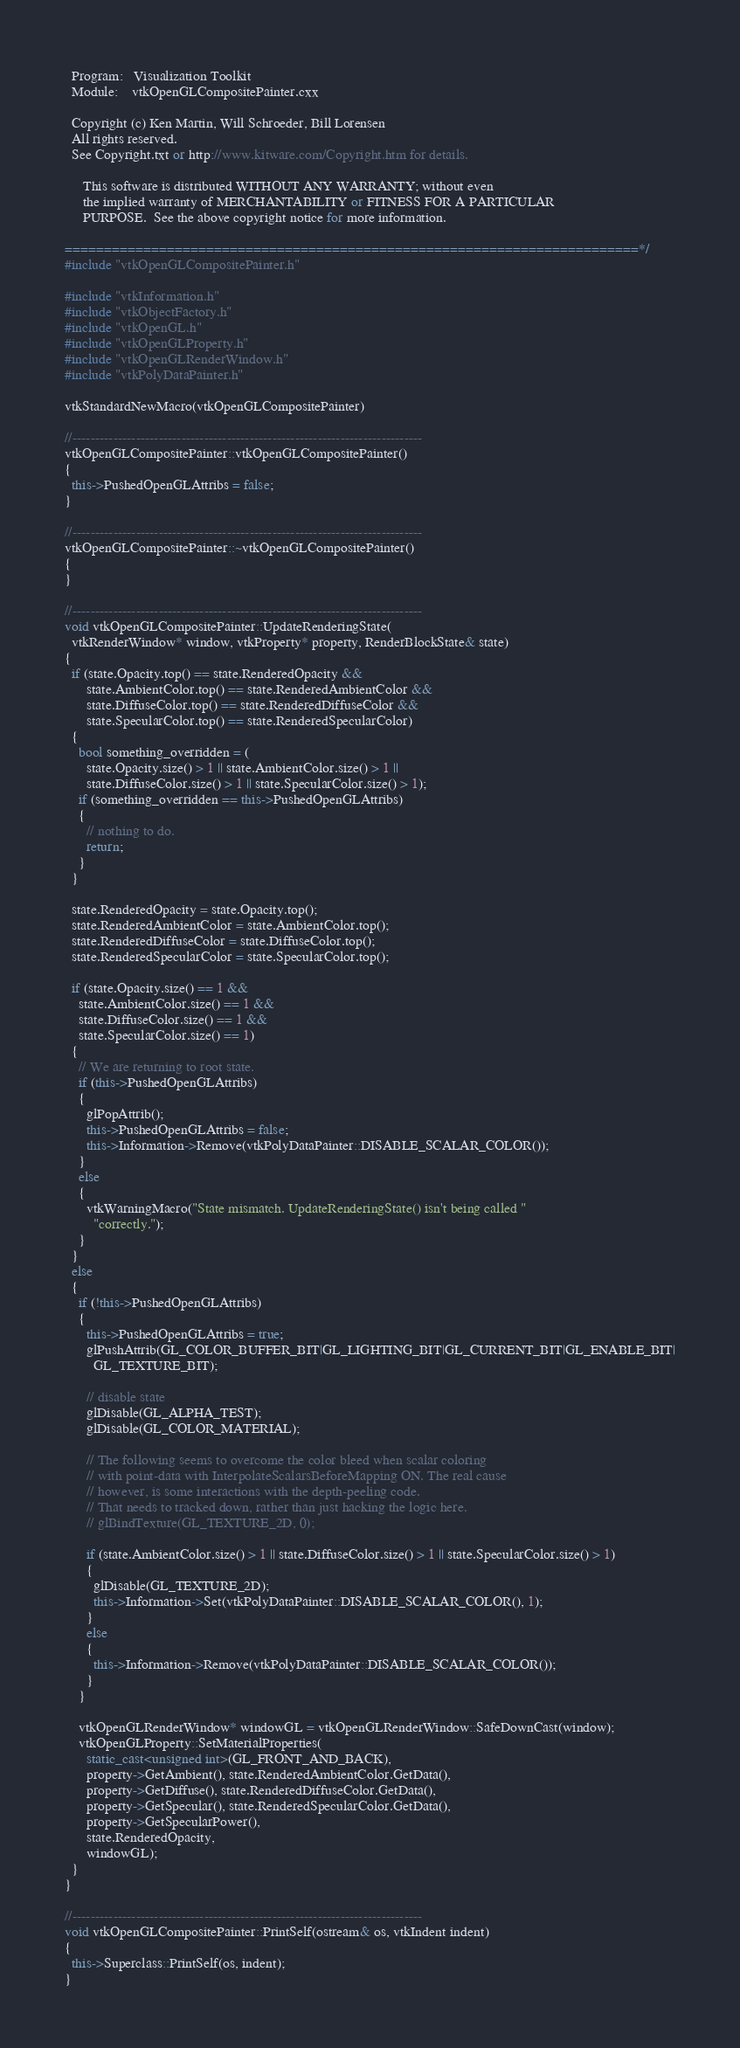Convert code to text. <code><loc_0><loc_0><loc_500><loc_500><_C++_>  Program:   Visualization Toolkit
  Module:    vtkOpenGLCompositePainter.cxx

  Copyright (c) Ken Martin, Will Schroeder, Bill Lorensen
  All rights reserved.
  See Copyright.txt or http://www.kitware.com/Copyright.htm for details.

     This software is distributed WITHOUT ANY WARRANTY; without even
     the implied warranty of MERCHANTABILITY or FITNESS FOR A PARTICULAR
     PURPOSE.  See the above copyright notice for more information.

=========================================================================*/
#include "vtkOpenGLCompositePainter.h"

#include "vtkInformation.h"
#include "vtkObjectFactory.h"
#include "vtkOpenGL.h"
#include "vtkOpenGLProperty.h"
#include "vtkOpenGLRenderWindow.h"
#include "vtkPolyDataPainter.h"

vtkStandardNewMacro(vtkOpenGLCompositePainter)

//-----------------------------------------------------------------------------
vtkOpenGLCompositePainter::vtkOpenGLCompositePainter()
{
  this->PushedOpenGLAttribs = false;
}

//-----------------------------------------------------------------------------
vtkOpenGLCompositePainter::~vtkOpenGLCompositePainter()
{
}

//-----------------------------------------------------------------------------
void vtkOpenGLCompositePainter::UpdateRenderingState(
  vtkRenderWindow* window, vtkProperty* property, RenderBlockState& state)
{
  if (state.Opacity.top() == state.RenderedOpacity &&
      state.AmbientColor.top() == state.RenderedAmbientColor &&
      state.DiffuseColor.top() == state.RenderedDiffuseColor &&
      state.SpecularColor.top() == state.RenderedSpecularColor)
  {
    bool something_overridden = (
      state.Opacity.size() > 1 || state.AmbientColor.size() > 1 ||
      state.DiffuseColor.size() > 1 || state.SpecularColor.size() > 1);
    if (something_overridden == this->PushedOpenGLAttribs)
    {
      // nothing to do.
      return;
    }
  }

  state.RenderedOpacity = state.Opacity.top();
  state.RenderedAmbientColor = state.AmbientColor.top();
  state.RenderedDiffuseColor = state.DiffuseColor.top();
  state.RenderedSpecularColor = state.SpecularColor.top();

  if (state.Opacity.size() == 1 &&
    state.AmbientColor.size() == 1 &&
    state.DiffuseColor.size() == 1 &&
    state.SpecularColor.size() == 1)
  {
    // We are returning to root state.
    if (this->PushedOpenGLAttribs)
    {
      glPopAttrib();
      this->PushedOpenGLAttribs = false;
      this->Information->Remove(vtkPolyDataPainter::DISABLE_SCALAR_COLOR());
    }
    else
    {
      vtkWarningMacro("State mismatch. UpdateRenderingState() isn't being called "
        "correctly.");
    }
  }
  else
  {
    if (!this->PushedOpenGLAttribs)
    {
      this->PushedOpenGLAttribs = true;
      glPushAttrib(GL_COLOR_BUFFER_BIT|GL_LIGHTING_BIT|GL_CURRENT_BIT|GL_ENABLE_BIT|
        GL_TEXTURE_BIT);

      // disable state
      glDisable(GL_ALPHA_TEST);
      glDisable(GL_COLOR_MATERIAL);

      // The following seems to overcome the color bleed when scalar coloring
      // with point-data with InterpolateScalarsBeforeMapping ON. The real cause
      // however, is some interactions with the depth-peeling code.
      // That needs to tracked down, rather than just hacking the logic here.
      // glBindTexture(GL_TEXTURE_2D, 0);

      if (state.AmbientColor.size() > 1 || state.DiffuseColor.size() > 1 || state.SpecularColor.size() > 1)
      {
        glDisable(GL_TEXTURE_2D);
        this->Information->Set(vtkPolyDataPainter::DISABLE_SCALAR_COLOR(), 1);
      }
      else
      {
        this->Information->Remove(vtkPolyDataPainter::DISABLE_SCALAR_COLOR());
      }
    }

    vtkOpenGLRenderWindow* windowGL = vtkOpenGLRenderWindow::SafeDownCast(window);
    vtkOpenGLProperty::SetMaterialProperties(
      static_cast<unsigned int>(GL_FRONT_AND_BACK),
      property->GetAmbient(), state.RenderedAmbientColor.GetData(),
      property->GetDiffuse(), state.RenderedDiffuseColor.GetData(),
      property->GetSpecular(), state.RenderedSpecularColor.GetData(),
      property->GetSpecularPower(),
      state.RenderedOpacity,
      windowGL);
  }
}

//-----------------------------------------------------------------------------
void vtkOpenGLCompositePainter::PrintSelf(ostream& os, vtkIndent indent)
{
  this->Superclass::PrintSelf(os, indent);
}
</code> 